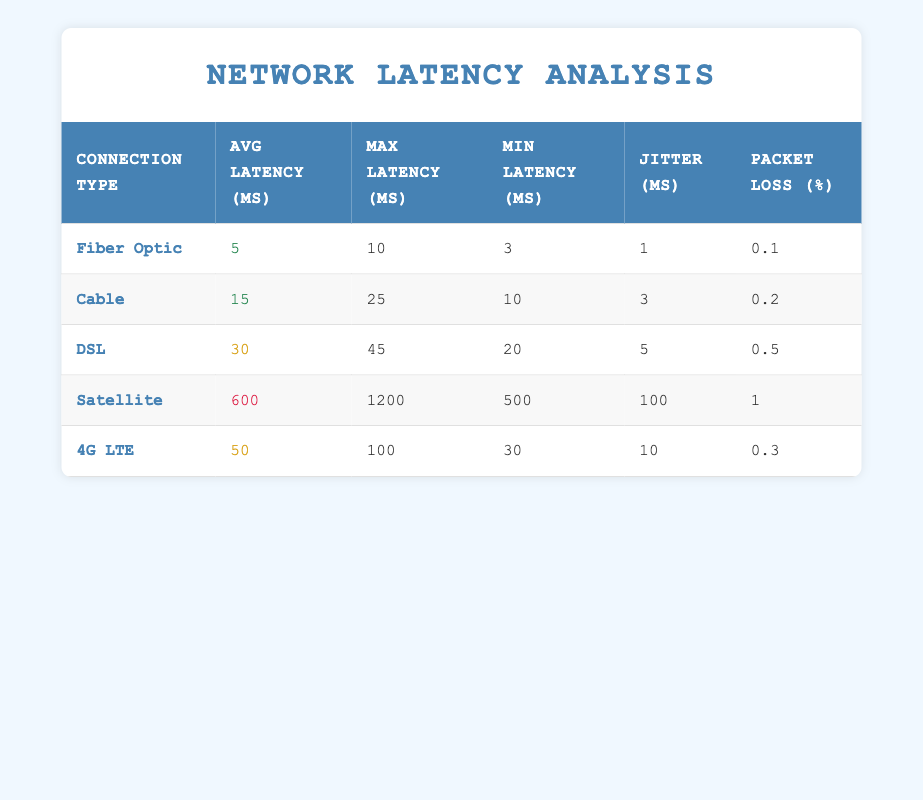What is the average latency for Cable connections? The average latency for Cable connections is listed in the table under the "Avg Latency (ms)" column for that connection type, which shows the value 15.
Answer: 15 Which connection type has the highest max latency? By reviewing the "Max Latency (ms)" column in the table, Satellite shows the highest value at 1200.
Answer: Satellite Is the packet loss percentage for Fiber Optic greater than 0.1%? Looking at the "Packet Loss (%)" column, Fiber Optic shows a value of 0.1%, indicating that it is not greater than this value.
Answer: No What is the difference in average latency between DSL and 4G LTE? The average latency for DSL is 30 ms, while for 4G LTE it is 50 ms. The difference can be calculated as 50 - 30 = 20 ms.
Answer: 20 Which connection type has the lowest jitter? The table lists the jitter values in the "Jitter (ms)" column, where Fiber Optic has the lowest value of 1 ms.
Answer: Fiber Optic Are the average latencies for Cable and DSL both below 40 ms? Checking the "Avg Latency (ms)" values, Cable is 15 ms and DSL is 30 ms, both are below 40 ms. So the statement is true.
Answer: Yes What is the total packet loss percentage for all connection types combined? The packet loss percentages are taken from the "Packet Loss (%)" column: 0.1 + 0.2 + 0.5 + 1 + 0.3 = 2.1%. This is the total packet loss percentage across all types.
Answer: 2.1 What is the average min latency across all connection types? The min latencies from the table are 3, 10, 20, 500, and 30. Summing and averaging these values gives (3 + 10 + 20 + 500 + 30) = 563, and there are 5 connection types, so the average is 563 / 5 = 112.6 ms.
Answer: 112.6 How many connection types listed have an average latency greater than 20 ms? By examining the "Avg Latency (ms)" column, DSL (30), Satellite (600), and 4G LTE (50) each have average latencies greater than 20 ms, totaling four types.
Answer: 3 